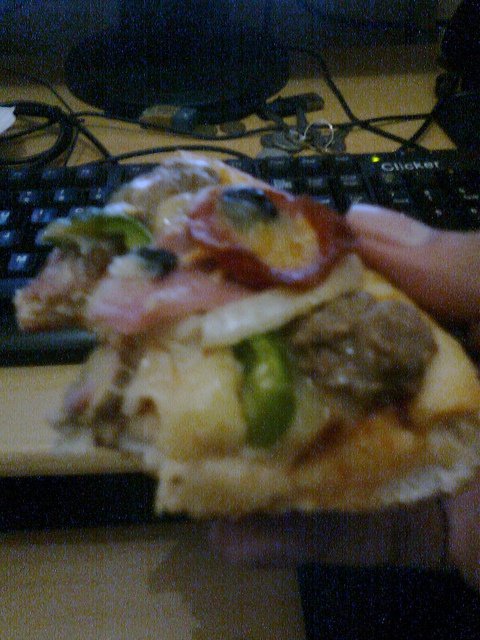Describe the objects in this image and their specific colors. I can see pizza in navy, olive, gray, black, and maroon tones, keyboard in navy, black, blue, and gray tones, and people in navy, gray, maroon, black, and olive tones in this image. 